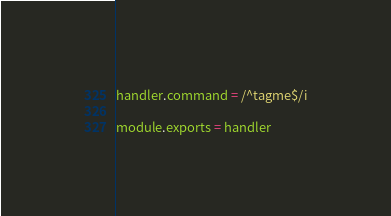Convert code to text. <code><loc_0><loc_0><loc_500><loc_500><_JavaScript_>
handler.command = /^tagme$/i

module.exports = handler</code> 